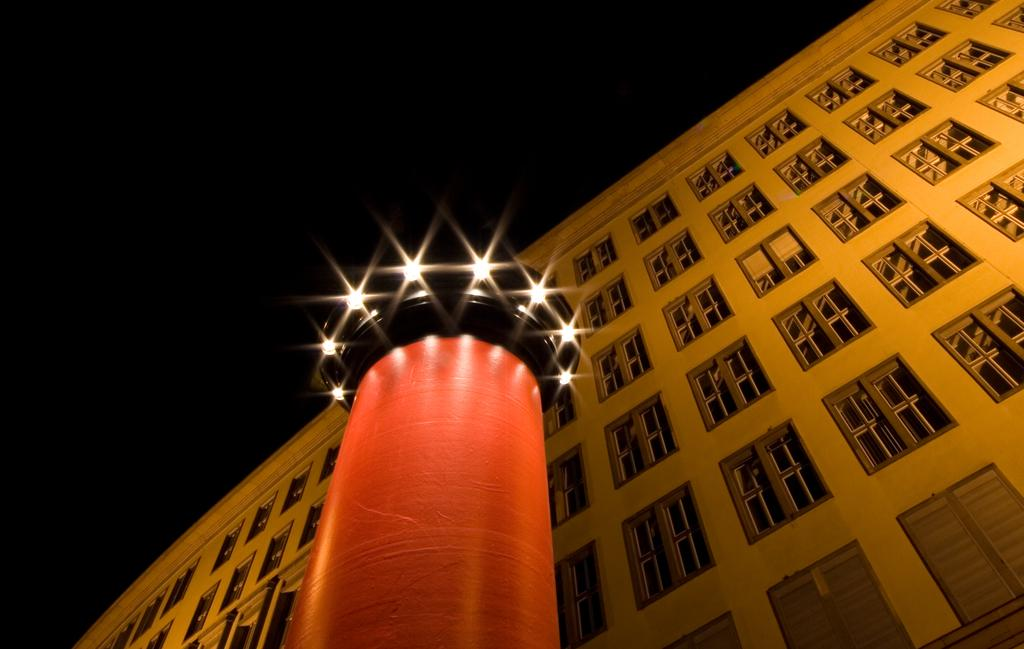What is the main structure in the image? There is a red color lighthouse tower in the image. What feature does the lighthouse tower have? The lighthouse tower has many spotlights. What other building can be seen in the image? There is a yellow color big building with many windows in the image. How would you describe the sky in the image? The sky is dark in the image. What type of box is being used for the vacation in the image? There is no box or vacation mentioned in the image; it features a red lighthouse tower and a yellow building. How many eyes can be seen on the lighthouse tower in the image? There are no eyes present on the lighthouse tower in the image. 